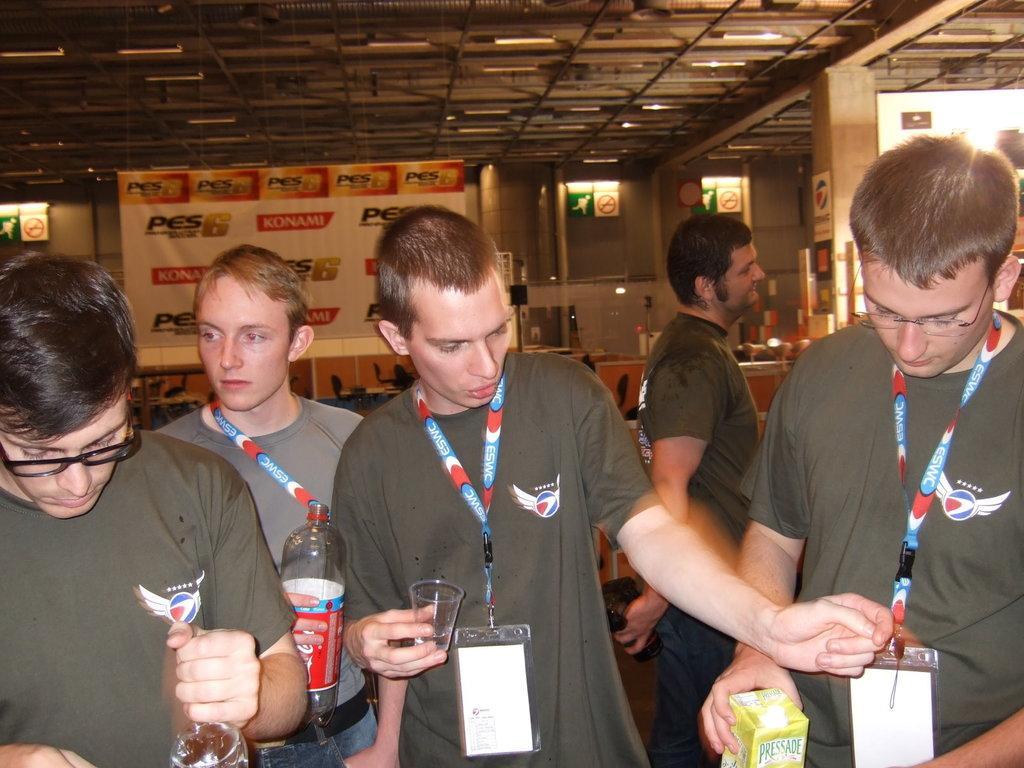In one or two sentences, can you explain what this image depicts? In this picture we can see group of people, in the middle of the image we can see a man, he is holding a glass, beside him we can find another man, he is holding a bottle, in the background we can see a hoarding, sign boards and lights. 